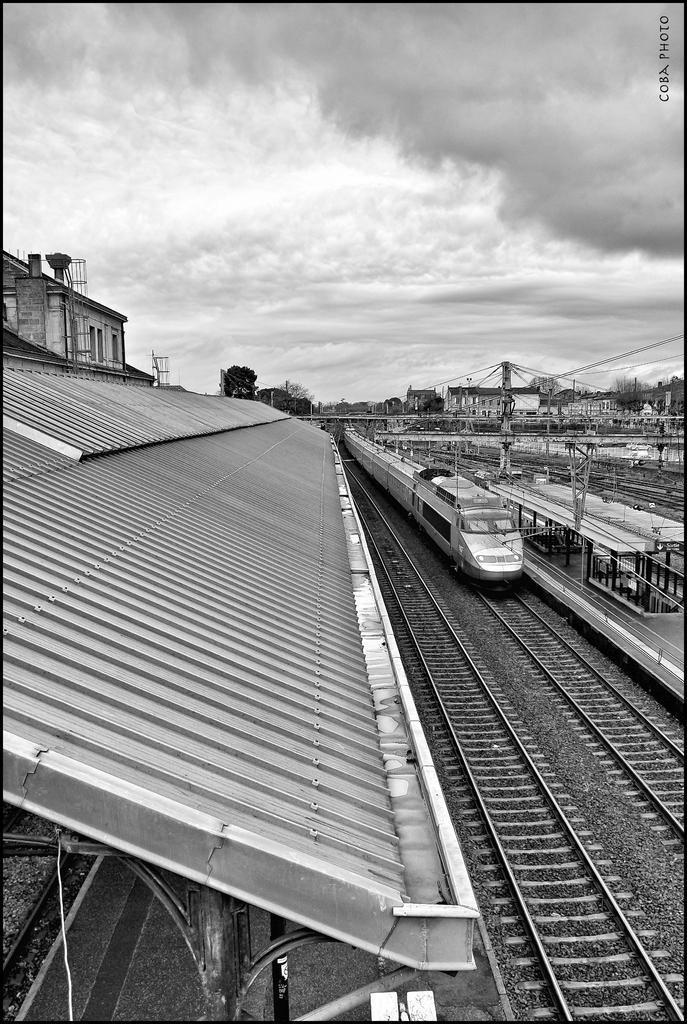Describe this image in one or two sentences. This is a black and white image. I can see a train on the railway track. There are buildings, trees, poles, wires and a roof. In the background, there is the sky. At the top right side of the image, I can see a watermark. 